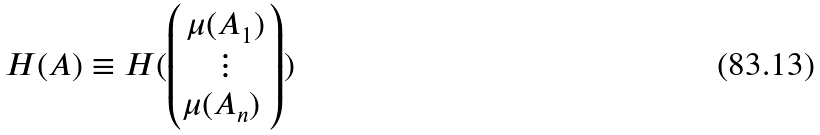<formula> <loc_0><loc_0><loc_500><loc_500>H ( A ) \equiv H ( \begin{pmatrix} \mu ( A _ { 1 } ) \\ \vdots \\ \mu ( A _ { n } ) \ \end{pmatrix} )</formula> 